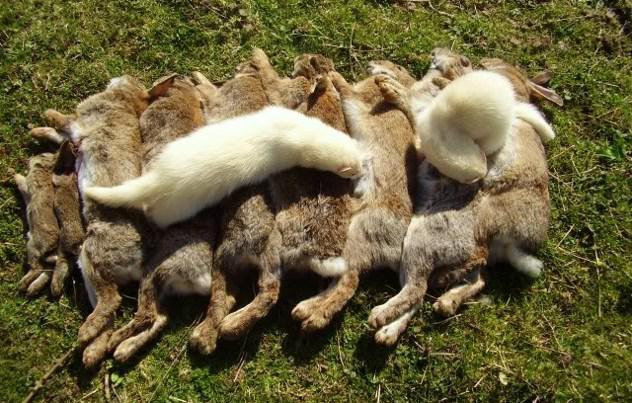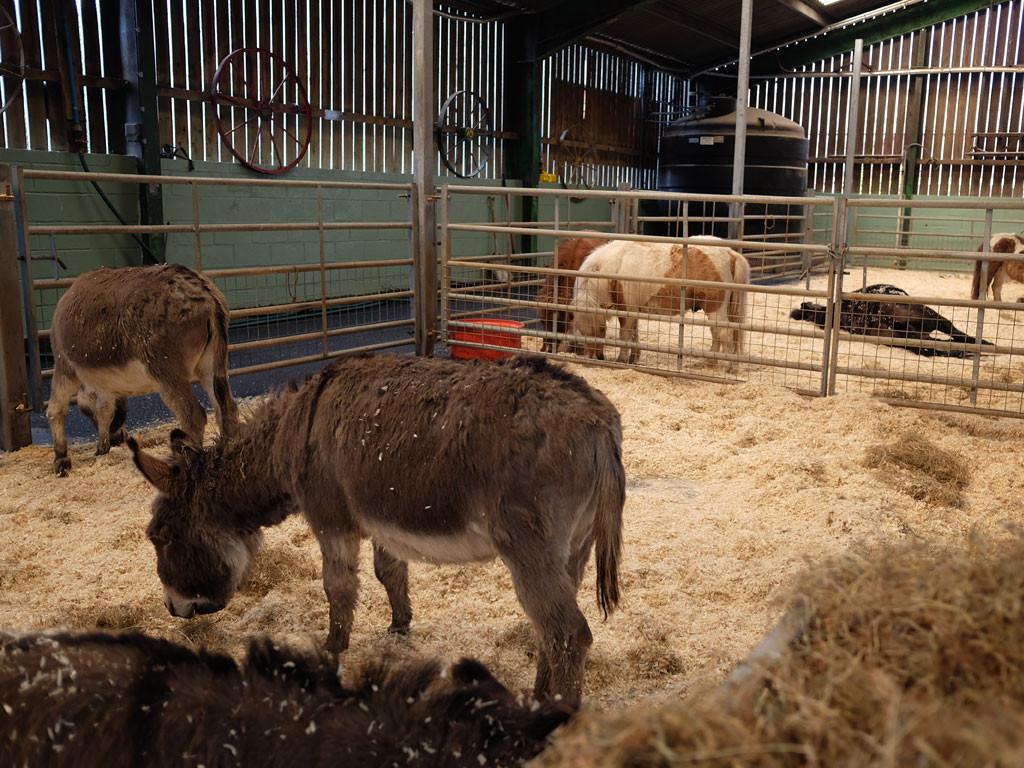The first image is the image on the left, the second image is the image on the right. Analyze the images presented: Is the assertion "The right image contains exactly two ferrets." valid? Answer yes or no. No. 